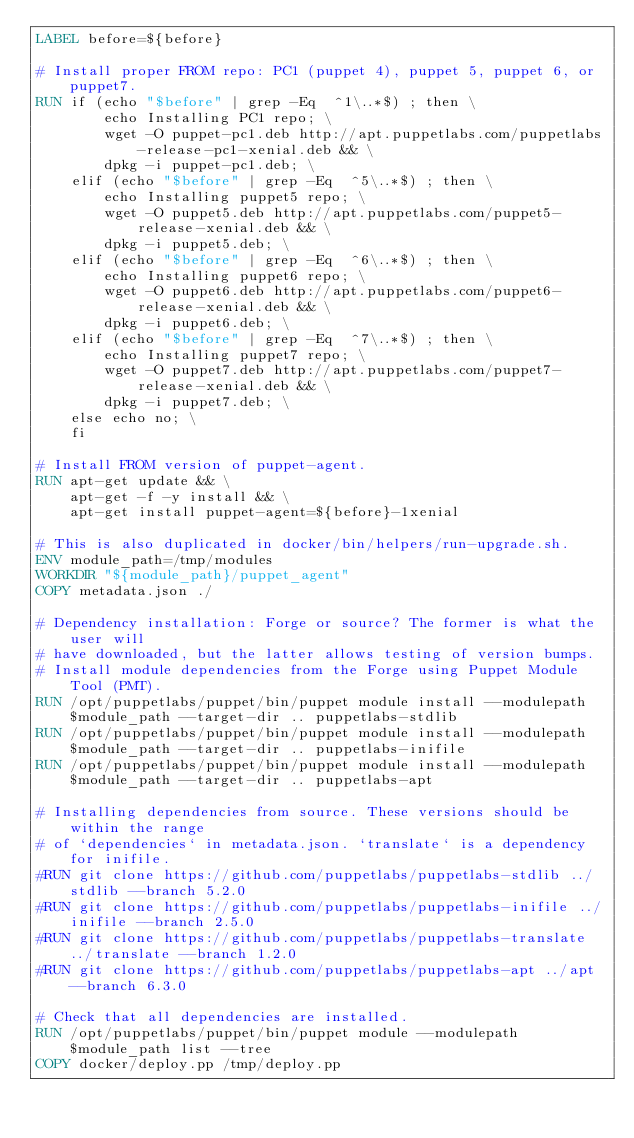<code> <loc_0><loc_0><loc_500><loc_500><_Dockerfile_>LABEL before=${before}

# Install proper FROM repo: PC1 (puppet 4), puppet 5, puppet 6, or puppet7.
RUN if (echo "$before" | grep -Eq  ^1\..*$) ; then \
        echo Installing PC1 repo; \
        wget -O puppet-pc1.deb http://apt.puppetlabs.com/puppetlabs-release-pc1-xenial.deb && \
        dpkg -i puppet-pc1.deb; \
    elif (echo "$before" | grep -Eq  ^5\..*$) ; then \
        echo Installing puppet5 repo; \
        wget -O puppet5.deb http://apt.puppetlabs.com/puppet5-release-xenial.deb && \
        dpkg -i puppet5.deb; \
    elif (echo "$before" | grep -Eq  ^6\..*$) ; then \
        echo Installing puppet6 repo; \
        wget -O puppet6.deb http://apt.puppetlabs.com/puppet6-release-xenial.deb && \
        dpkg -i puppet6.deb; \
    elif (echo "$before" | grep -Eq  ^7\..*$) ; then \
        echo Installing puppet7 repo; \
        wget -O puppet7.deb http://apt.puppetlabs.com/puppet7-release-xenial.deb && \
        dpkg -i puppet7.deb; \
    else echo no; \
    fi

# Install FROM version of puppet-agent.
RUN apt-get update && \
    apt-get -f -y install && \
    apt-get install puppet-agent=${before}-1xenial

# This is also duplicated in docker/bin/helpers/run-upgrade.sh.
ENV module_path=/tmp/modules
WORKDIR "${module_path}/puppet_agent"
COPY metadata.json ./

# Dependency installation: Forge or source? The former is what the user will
# have downloaded, but the latter allows testing of version bumps.
# Install module dependencies from the Forge using Puppet Module Tool (PMT).
RUN /opt/puppetlabs/puppet/bin/puppet module install --modulepath $module_path --target-dir .. puppetlabs-stdlib
RUN /opt/puppetlabs/puppet/bin/puppet module install --modulepath $module_path --target-dir .. puppetlabs-inifile
RUN /opt/puppetlabs/puppet/bin/puppet module install --modulepath $module_path --target-dir .. puppetlabs-apt

# Installing dependencies from source. These versions should be within the range
# of `dependencies` in metadata.json. `translate` is a dependency for inifile.
#RUN git clone https://github.com/puppetlabs/puppetlabs-stdlib ../stdlib --branch 5.2.0
#RUN git clone https://github.com/puppetlabs/puppetlabs-inifile ../inifile --branch 2.5.0
#RUN git clone https://github.com/puppetlabs/puppetlabs-translate ../translate --branch 1.2.0
#RUN git clone https://github.com/puppetlabs/puppetlabs-apt ../apt --branch 6.3.0

# Check that all dependencies are installed.
RUN /opt/puppetlabs/puppet/bin/puppet module --modulepath $module_path list --tree
COPY docker/deploy.pp /tmp/deploy.pp</code> 